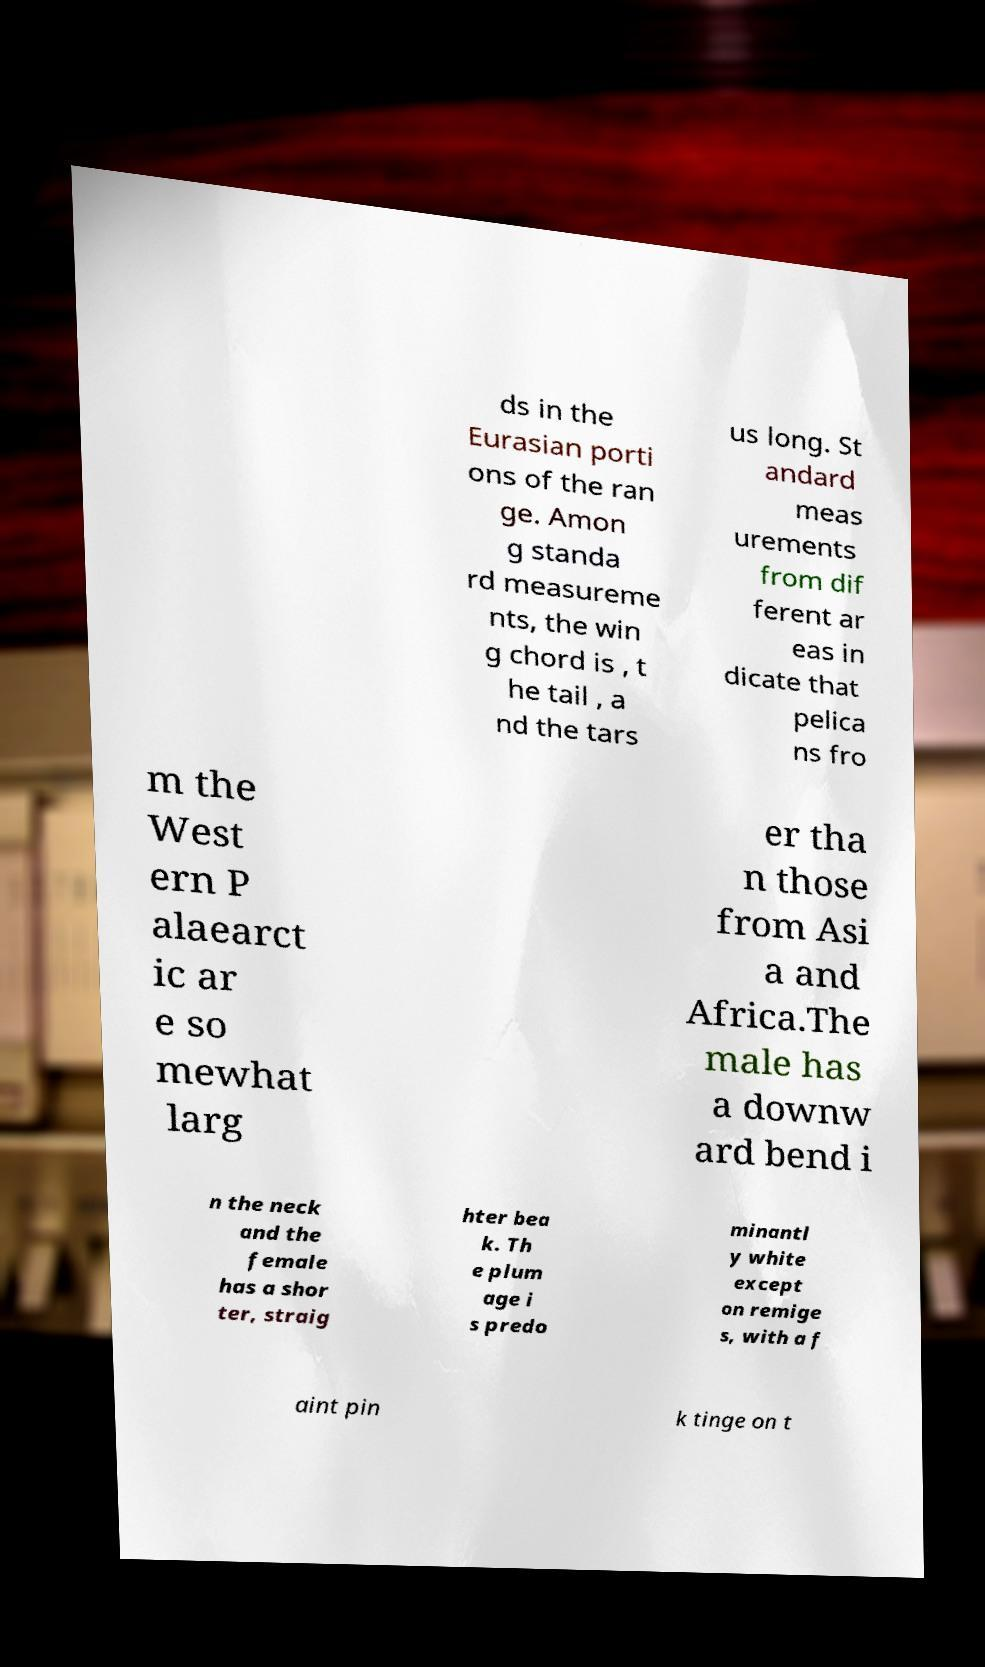I need the written content from this picture converted into text. Can you do that? ds in the Eurasian porti ons of the ran ge. Amon g standa rd measureme nts, the win g chord is , t he tail , a nd the tars us long. St andard meas urements from dif ferent ar eas in dicate that pelica ns fro m the West ern P alaearct ic ar e so mewhat larg er tha n those from Asi a and Africa.The male has a downw ard bend i n the neck and the female has a shor ter, straig hter bea k. Th e plum age i s predo minantl y white except on remige s, with a f aint pin k tinge on t 